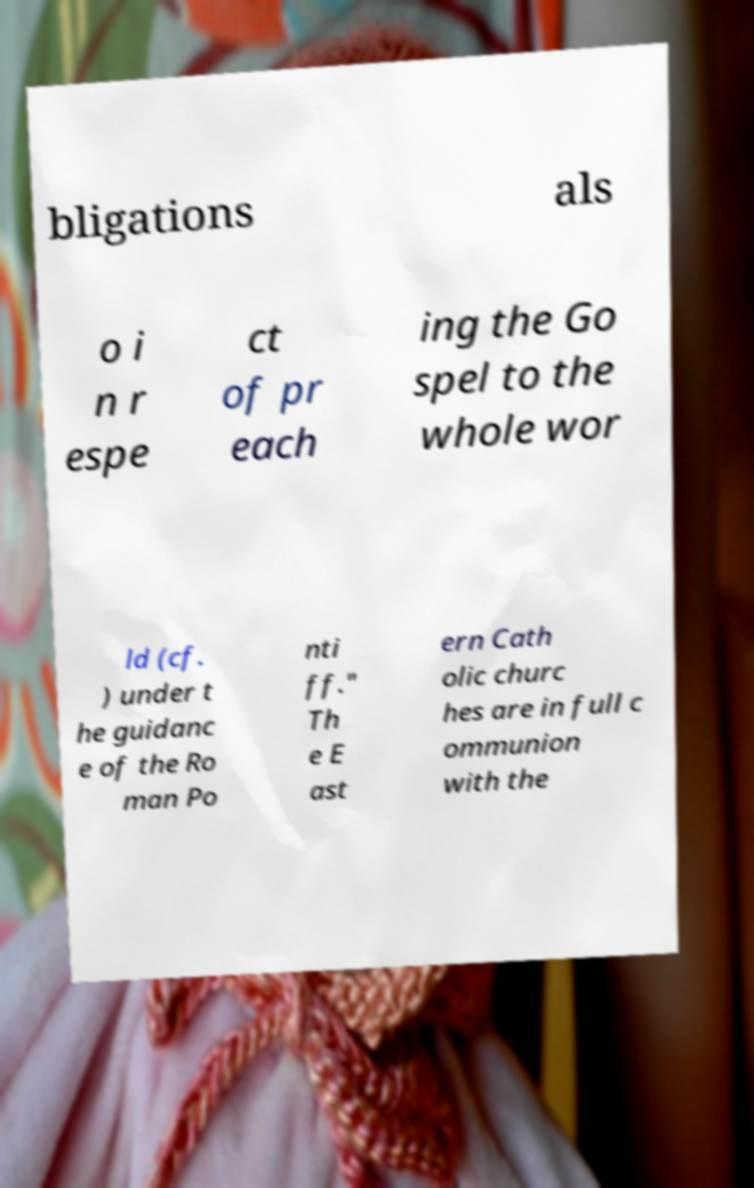For documentation purposes, I need the text within this image transcribed. Could you provide that? bligations als o i n r espe ct of pr each ing the Go spel to the whole wor ld (cf. ) under t he guidanc e of the Ro man Po nti ff." Th e E ast ern Cath olic churc hes are in full c ommunion with the 